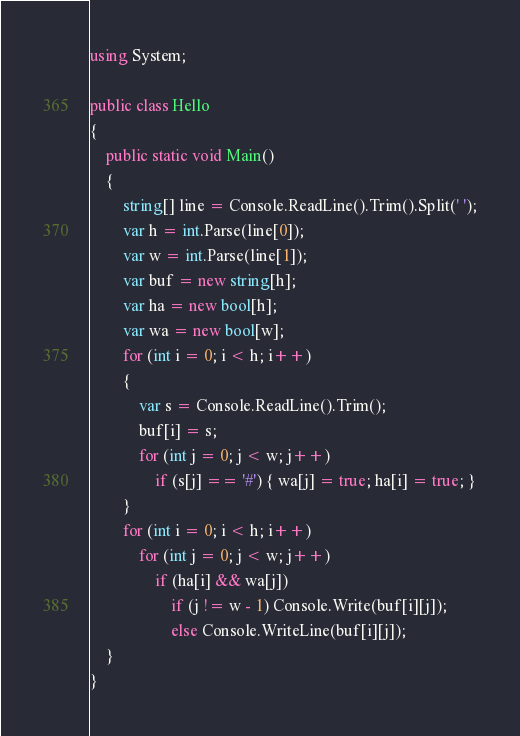<code> <loc_0><loc_0><loc_500><loc_500><_C#_>using System;

public class Hello
{
    public static void Main()
    {
        string[] line = Console.ReadLine().Trim().Split(' ');
        var h = int.Parse(line[0]);
        var w = int.Parse(line[1]);
        var buf = new string[h];
        var ha = new bool[h];
        var wa = new bool[w];
        for (int i = 0; i < h; i++)
        {
            var s = Console.ReadLine().Trim();
            buf[i] = s;
            for (int j = 0; j < w; j++)
                if (s[j] == '#') { wa[j] = true; ha[i] = true; }
        }
        for (int i = 0; i < h; i++)
            for (int j = 0; j < w; j++)
                if (ha[i] && wa[j])
                    if (j != w - 1) Console.Write(buf[i][j]);
                    else Console.WriteLine(buf[i][j]);
    }
}
</code> 